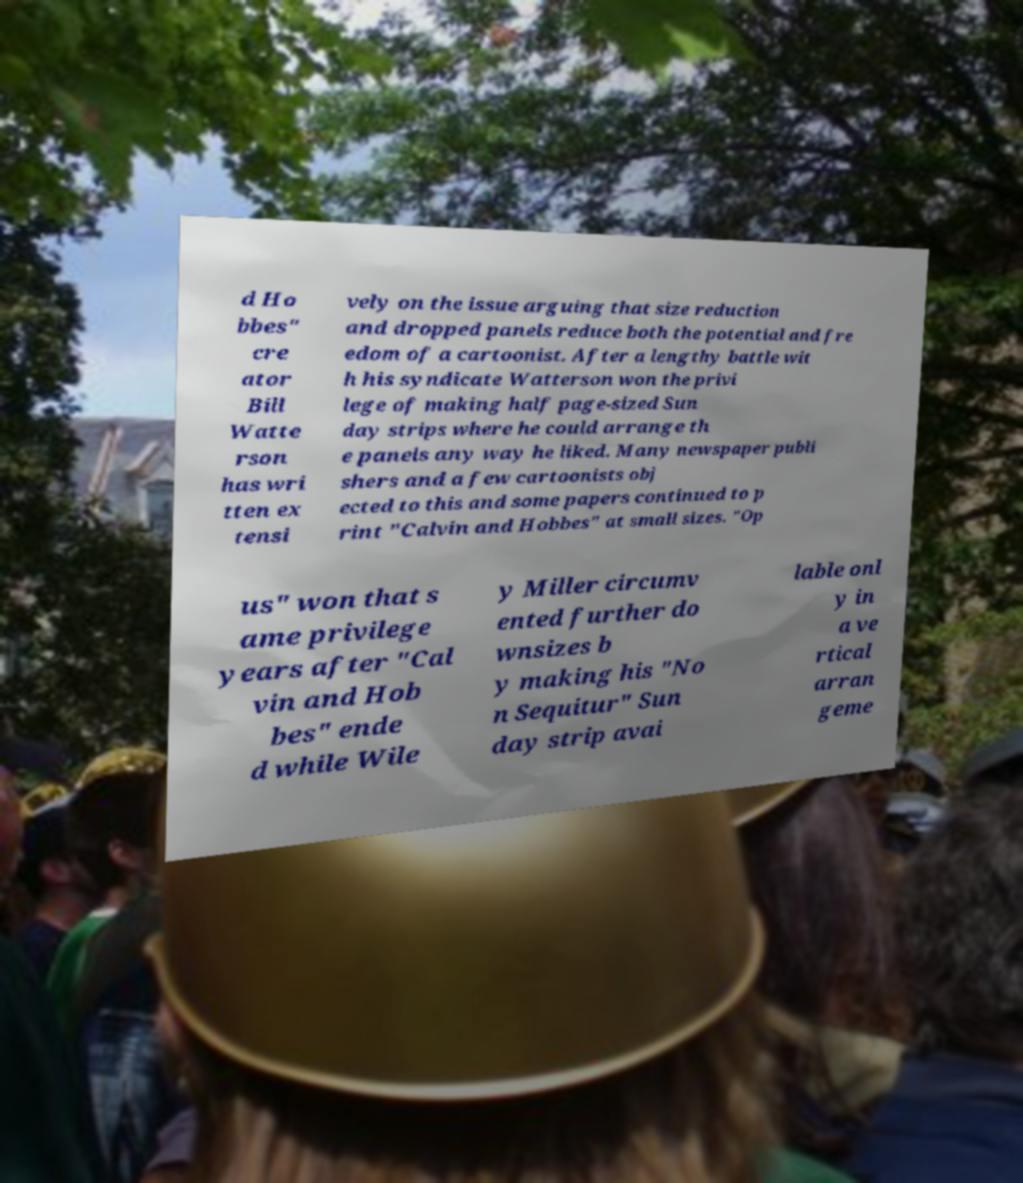For documentation purposes, I need the text within this image transcribed. Could you provide that? d Ho bbes" cre ator Bill Watte rson has wri tten ex tensi vely on the issue arguing that size reduction and dropped panels reduce both the potential and fre edom of a cartoonist. After a lengthy battle wit h his syndicate Watterson won the privi lege of making half page-sized Sun day strips where he could arrange th e panels any way he liked. Many newspaper publi shers and a few cartoonists obj ected to this and some papers continued to p rint "Calvin and Hobbes" at small sizes. "Op us" won that s ame privilege years after "Cal vin and Hob bes" ende d while Wile y Miller circumv ented further do wnsizes b y making his "No n Sequitur" Sun day strip avai lable onl y in a ve rtical arran geme 